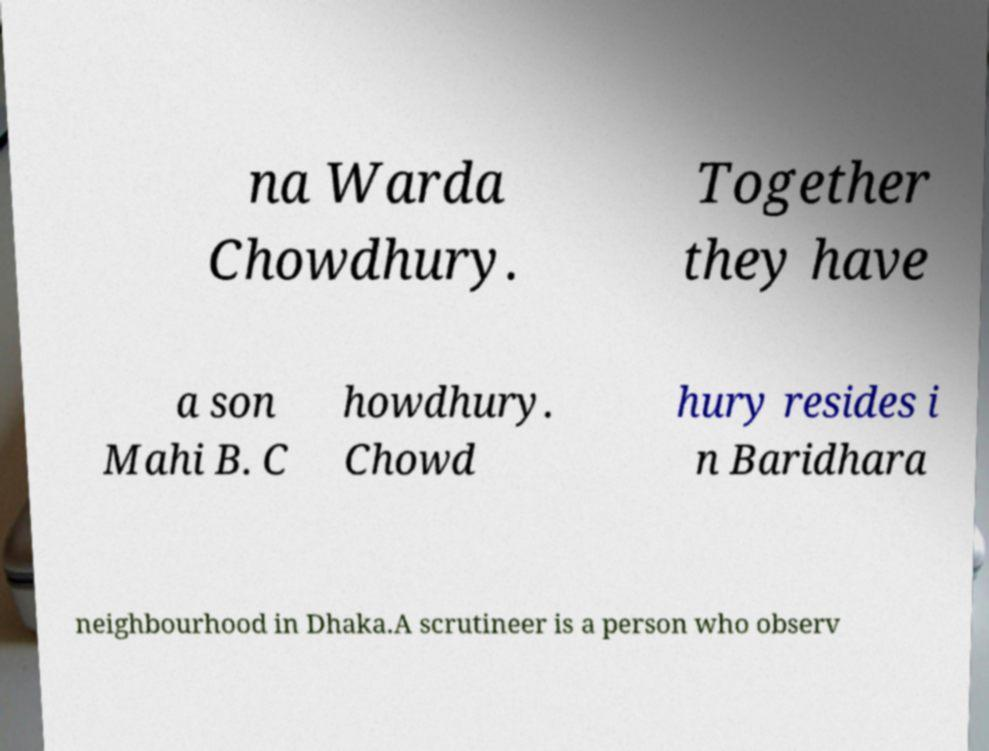For documentation purposes, I need the text within this image transcribed. Could you provide that? na Warda Chowdhury. Together they have a son Mahi B. C howdhury. Chowd hury resides i n Baridhara neighbourhood in Dhaka.A scrutineer is a person who observ 